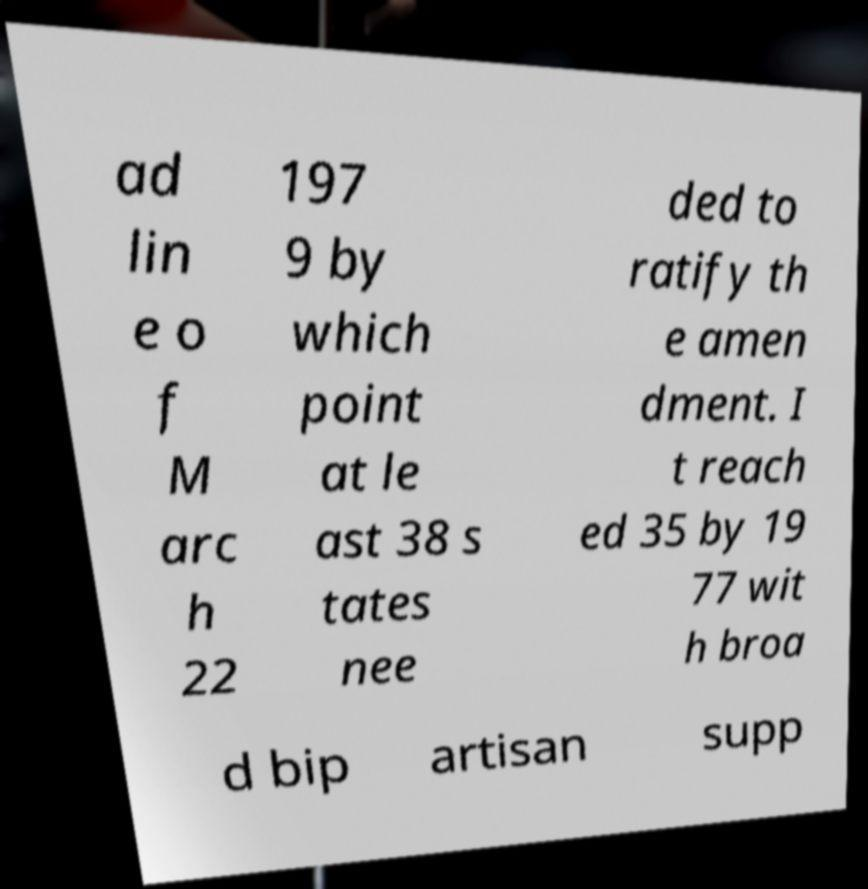Can you read and provide the text displayed in the image?This photo seems to have some interesting text. Can you extract and type it out for me? ad lin e o f M arc h 22 197 9 by which point at le ast 38 s tates nee ded to ratify th e amen dment. I t reach ed 35 by 19 77 wit h broa d bip artisan supp 